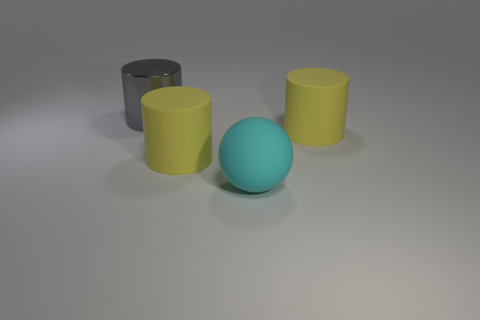There is a metallic cylinder that is behind the yellow cylinder in front of the big yellow matte object on the right side of the large cyan matte thing; what is its size?
Your response must be concise. Large. There is a thing that is both on the left side of the large cyan rubber ball and in front of the gray metal object; what is its size?
Your response must be concise. Large. What shape is the yellow rubber object that is in front of the large yellow cylinder right of the matte sphere?
Make the answer very short. Cylinder. Is there any other thing of the same color as the large shiny thing?
Your answer should be very brief. No. There is a yellow matte thing to the left of the large rubber sphere; what shape is it?
Your answer should be compact. Cylinder. The object that is both on the right side of the large gray thing and to the left of the cyan object has what shape?
Your answer should be very brief. Cylinder. What number of purple objects are either cylinders or metal objects?
Give a very brief answer. 0. Does the rubber thing that is right of the cyan rubber object have the same color as the sphere?
Your answer should be compact. No. There is a yellow thing that is left of the big yellow matte thing on the right side of the big ball; how big is it?
Ensure brevity in your answer.  Large. What material is the gray cylinder that is the same size as the cyan thing?
Offer a very short reply. Metal. 